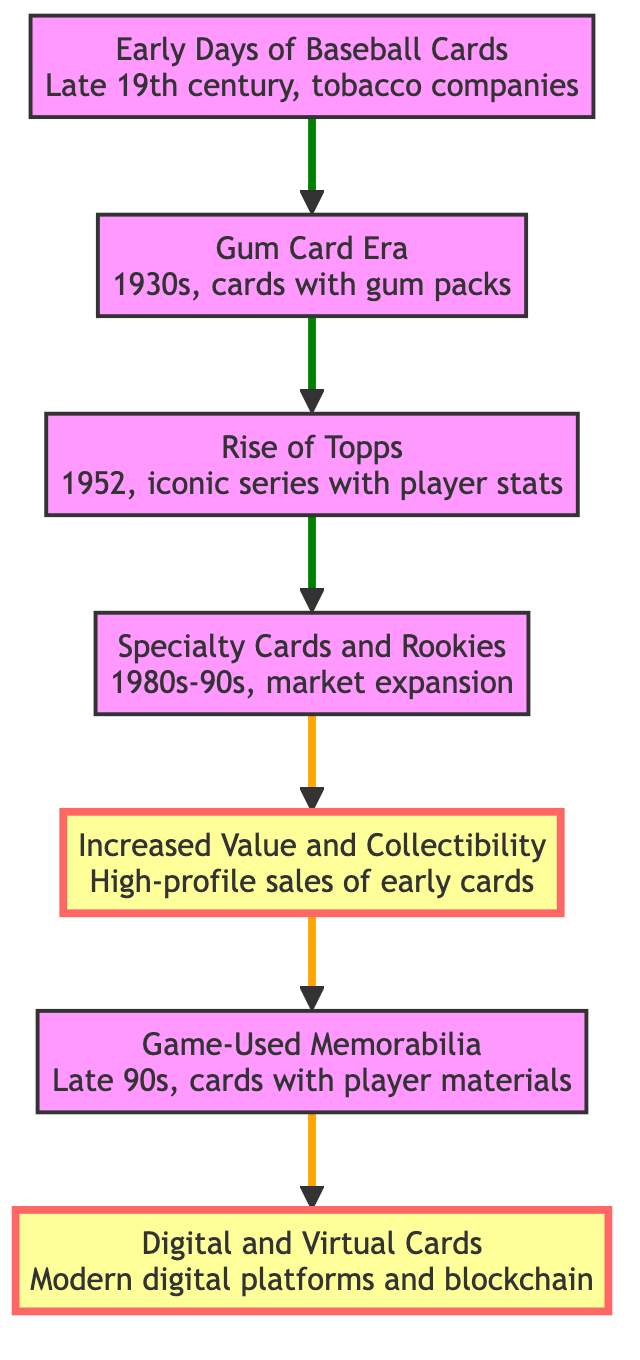What is the first stage in the evolution of baseball cards? The diagram indicates that the first stage is "Early Days of Baseball Cards," which occurred in the late 19th century by tobacco companies.
Answer: Early Days of Baseball Cards How many overall stages are shown in the diagram? By counting the nodes listed in the diagram, there are a total of seven stages outlined in the evolution of baseball cards.
Answer: 7 What decade did the Gum Card Era begin? The diagram specifies that the Gum Card Era started in the 1930s, indicating the decade of its inception.
Answer: 1930s Which node follows the Rise of Topps? The diagram shows that the node titled "Specialty Cards and Rookies" follows the Rise of Topps, indicating the progression in the evolution.
Answer: Specialty Cards and Rookies Which era introduced materials like player jerseys into card designs? According to the diagram, the era that introduced game-used materials like player jerseys is marked as "Introduction of Game-Used Memorabilia" in the late 90s.
Answer: Introduction of Game-Used Memorabilia What is the relationship between Increased Value and Collectibility and Game-Used Memorabilia? Analyzing the diagram, Increased Value and Collectibility precedes the Game-Used Memorabilia node, suggesting that the rising value contributed to the innovation of incorporating memorabilia into cards.
Answer: Increased Value and Collectibility What type of cards emerged as a result of modern technology? The diagram clearly states that "Digital and Virtual Cards" emerged as a result of advancements in modern technology, indicating the current trend in the collectible card market.
Answer: Digital and Virtual Cards 